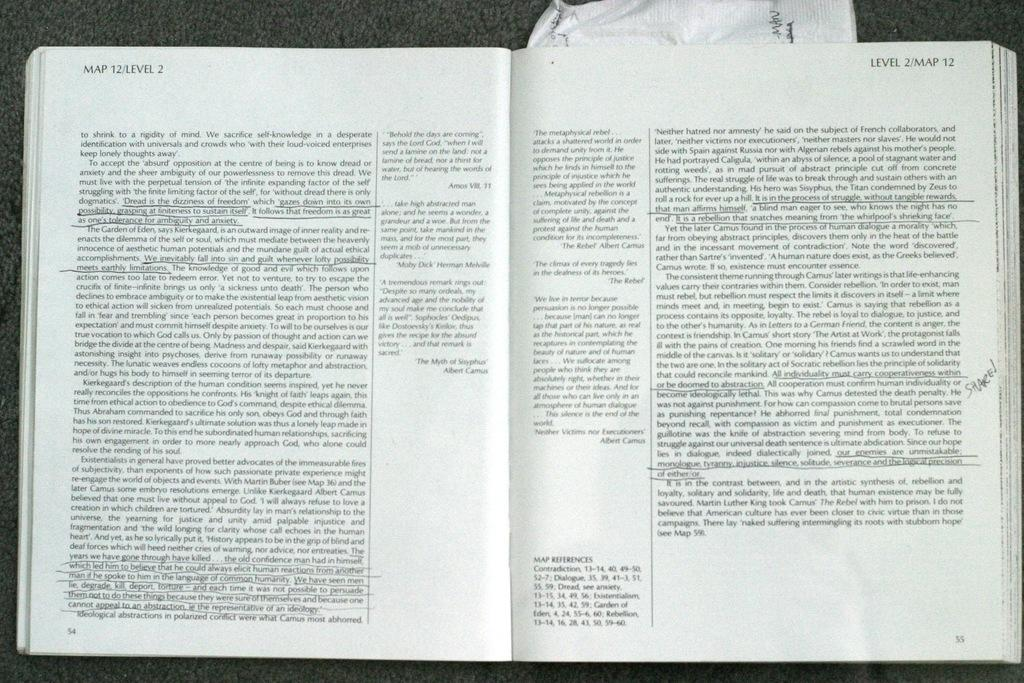<image>
Provide a brief description of the given image. a book that says 'map 12/level 2' on the top left corner of the open page 